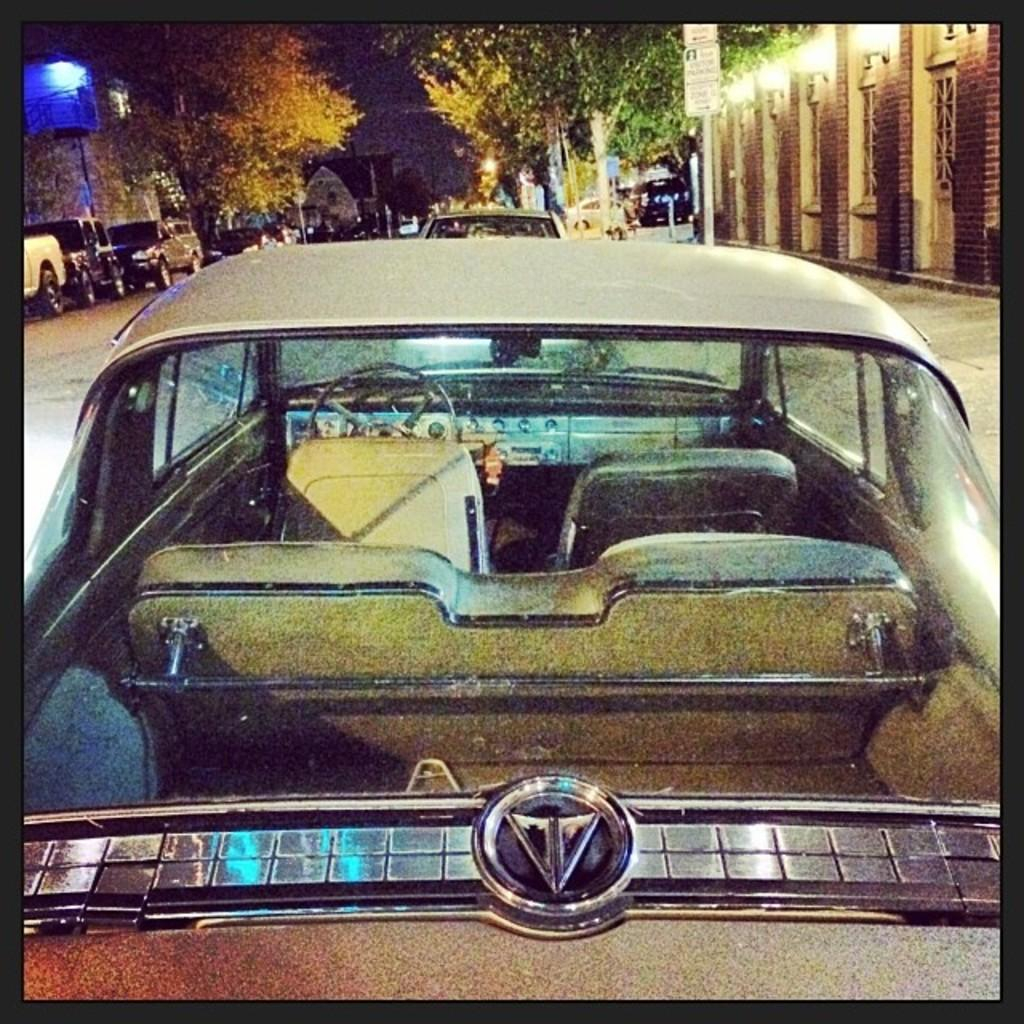What is the main subject of the image? The main subject of the image is a car. What type of natural vegetation can be seen in the image? There are trees visible at the top of the image. Where are the lights located in the image? The lights are on the right side of the image. What type of angle is the ship positioned at in the image? There is no ship present in the image. What is the chalk used for in the image? There is no chalk present in the image. 